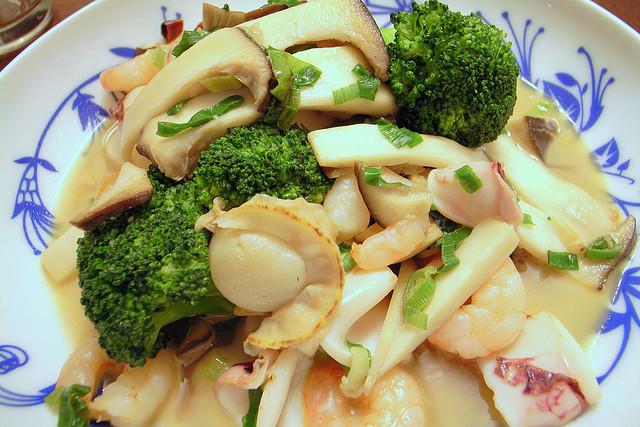What is mainly featured?
Keep it brief. Food. What color is the plate?
Short answer required. White and blue. What food is shown?
Concise answer only. Seafood. 